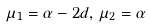<formula> <loc_0><loc_0><loc_500><loc_500>\mu _ { 1 } = \alpha - 2 d , \, \mu _ { 2 } = \alpha</formula> 